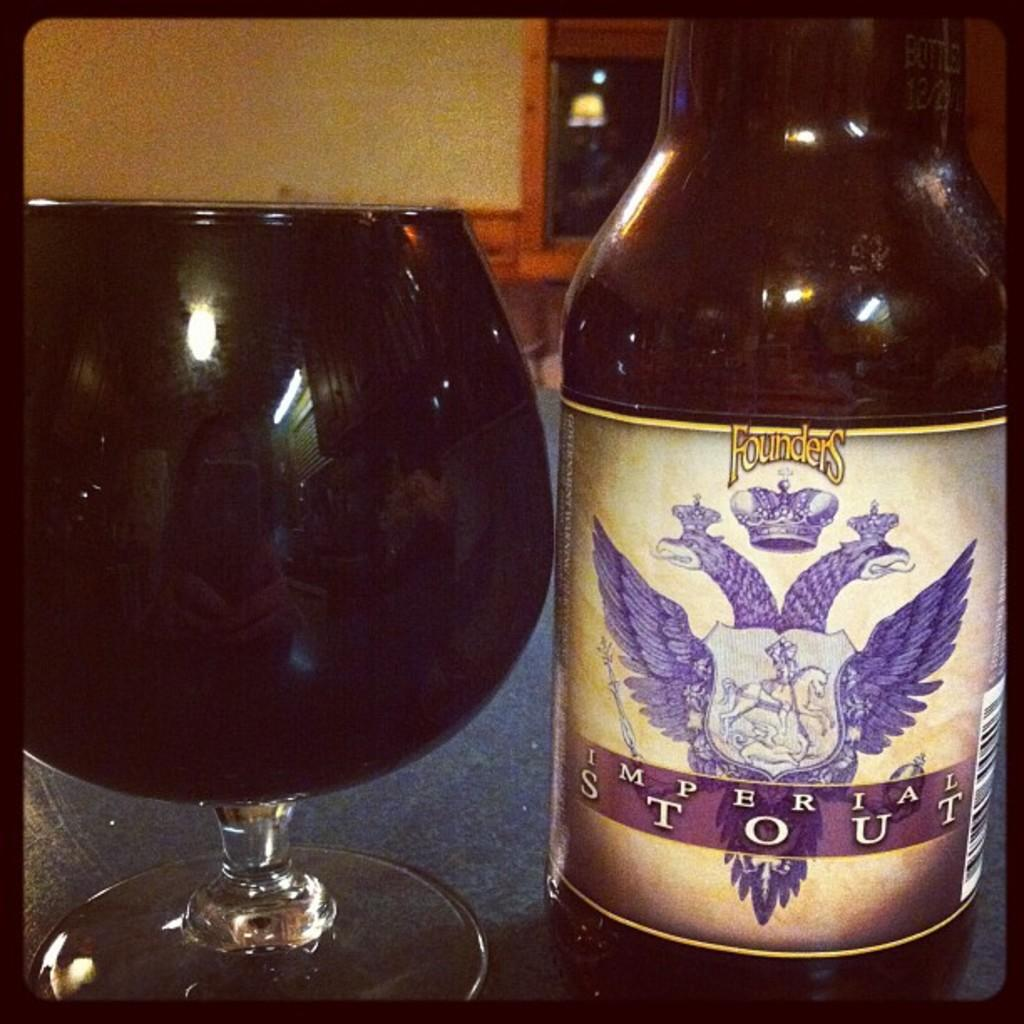What is present in the image alongside the glass? There is a bottle beside the glass in the image. What can be seen reflected on the glass? There is a reflection of a woman holding a mobile on the glass. Can you describe the contents of the glass? The contents of the glass are not visible in the image. What type of weather can be seen in the image? There is no indication of weather in the image, as it only features a glass, a bottle, and a reflection on the glass. Is there a knife visible in the image? There is no knife present in the image. 